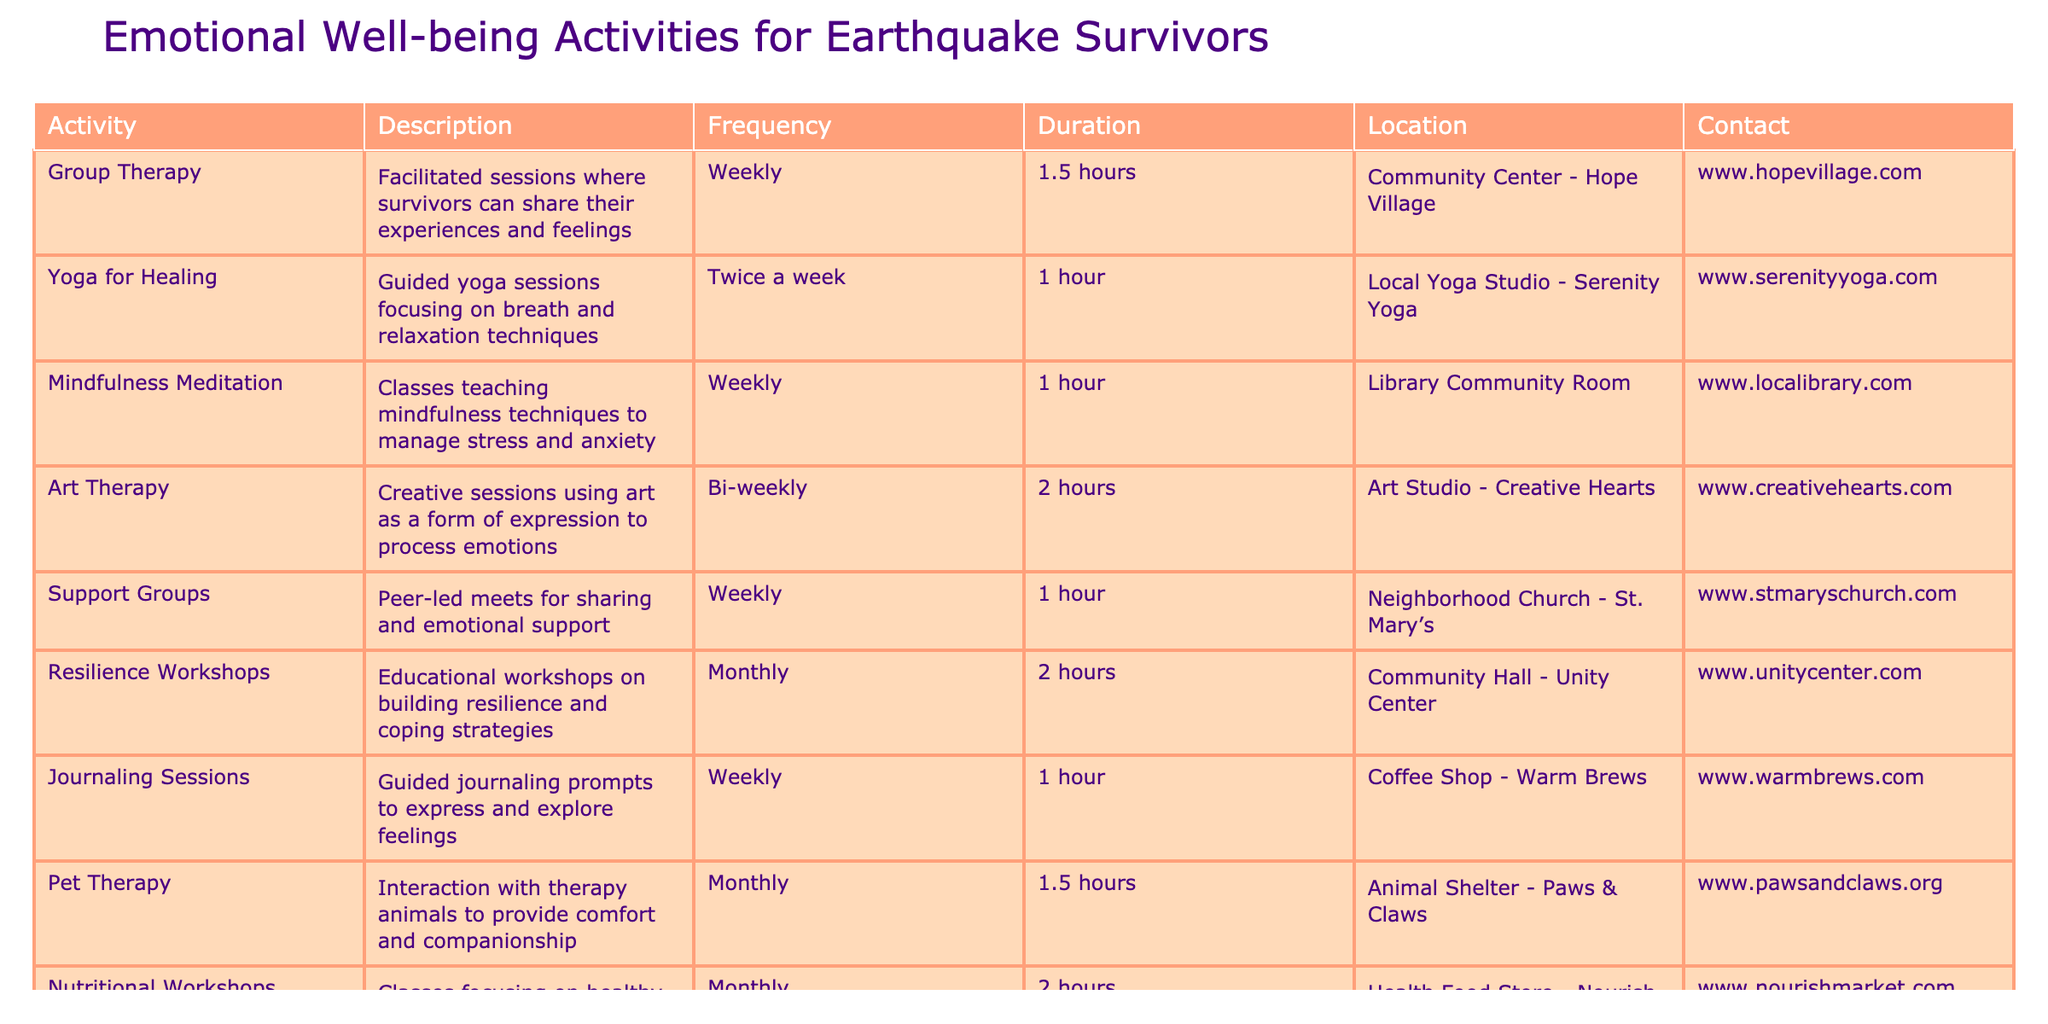What is the location of the Yoga for Healing activity? The table lists the Yoga for Healing activity and specifies its location, which is the Local Yoga Studio - Serenity Yoga.
Answer: Local Yoga Studio - Serenity Yoga How often do Support Groups meet? According to the table, Support Groups are listed to meet weekly, providing regular opportunities for survivors to gather.
Answer: Weekly What is the total duration of both the Nutritional Workshops and Resilience Workshops? The Nutritional Workshops last 2 hours and Resilience Workshops also last 2 hours. Summing these gives 2 + 2 = 4 hours in total.
Answer: 4 hours Is Art Therapy offered more than once a month? From the table, Art Therapy is offered bi-weekly, which means it occurs twice a month. Thus, it is confirmed that it is offered more than once a month.
Answer: Yes What are the average durations of emotional well-being activities listed in the table? The durations listed are 1.5, 1, 1, 2, 1, 2, 1, 1.5, and 2 hours. Adding these gives a total of 12 hours. There are 9 activities, so the average duration is 12 hours / 9 activities = approximately 1.33 hours.
Answer: Approximately 1.33 hours 